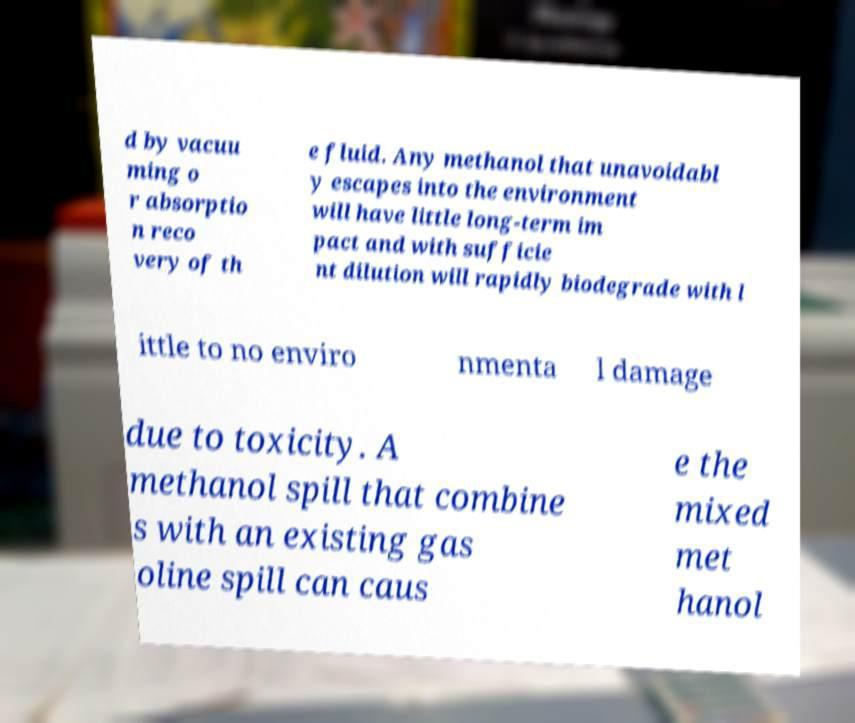I need the written content from this picture converted into text. Can you do that? d by vacuu ming o r absorptio n reco very of th e fluid. Any methanol that unavoidabl y escapes into the environment will have little long-term im pact and with sufficie nt dilution will rapidly biodegrade with l ittle to no enviro nmenta l damage due to toxicity. A methanol spill that combine s with an existing gas oline spill can caus e the mixed met hanol 